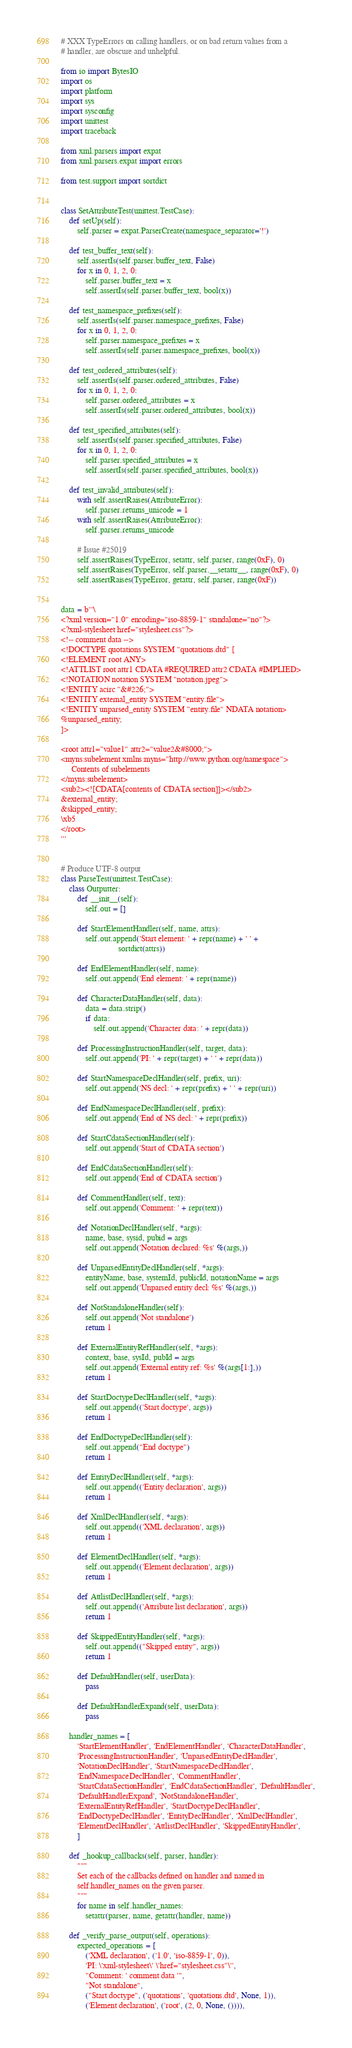<code> <loc_0><loc_0><loc_500><loc_500><_Python_># XXX TypeErrors on calling handlers, or on bad return values from a
# handler, are obscure and unhelpful.

from io import BytesIO
import os
import platform
import sys
import sysconfig
import unittest
import traceback

from xml.parsers import expat
from xml.parsers.expat import errors

from test.support import sortdict


class SetAttributeTest(unittest.TestCase):
    def setUp(self):
        self.parser = expat.ParserCreate(namespace_separator='!')

    def test_buffer_text(self):
        self.assertIs(self.parser.buffer_text, False)
        for x in 0, 1, 2, 0:
            self.parser.buffer_text = x
            self.assertIs(self.parser.buffer_text, bool(x))

    def test_namespace_prefixes(self):
        self.assertIs(self.parser.namespace_prefixes, False)
        for x in 0, 1, 2, 0:
            self.parser.namespace_prefixes = x
            self.assertIs(self.parser.namespace_prefixes, bool(x))

    def test_ordered_attributes(self):
        self.assertIs(self.parser.ordered_attributes, False)
        for x in 0, 1, 2, 0:
            self.parser.ordered_attributes = x
            self.assertIs(self.parser.ordered_attributes, bool(x))

    def test_specified_attributes(self):
        self.assertIs(self.parser.specified_attributes, False)
        for x in 0, 1, 2, 0:
            self.parser.specified_attributes = x
            self.assertIs(self.parser.specified_attributes, bool(x))

    def test_invalid_attributes(self):
        with self.assertRaises(AttributeError):
            self.parser.returns_unicode = 1
        with self.assertRaises(AttributeError):
            self.parser.returns_unicode

        # Issue #25019
        self.assertRaises(TypeError, setattr, self.parser, range(0xF), 0)
        self.assertRaises(TypeError, self.parser.__setattr__, range(0xF), 0)
        self.assertRaises(TypeError, getattr, self.parser, range(0xF))


data = b'''\
<?xml version="1.0" encoding="iso-8859-1" standalone="no"?>
<?xml-stylesheet href="stylesheet.css"?>
<!-- comment data -->
<!DOCTYPE quotations SYSTEM "quotations.dtd" [
<!ELEMENT root ANY>
<!ATTLIST root attr1 CDATA #REQUIRED attr2 CDATA #IMPLIED>
<!NOTATION notation SYSTEM "notation.jpeg">
<!ENTITY acirc "&#226;">
<!ENTITY external_entity SYSTEM "entity.file">
<!ENTITY unparsed_entity SYSTEM "entity.file" NDATA notation>
%unparsed_entity;
]>

<root attr1="value1" attr2="value2&#8000;">
<myns:subelement xmlns:myns="http://www.python.org/namespace">
     Contents of subelements
</myns:subelement>
<sub2><![CDATA[contents of CDATA section]]></sub2>
&external_entity;
&skipped_entity;
\xb5
</root>
'''


# Produce UTF-8 output
class ParseTest(unittest.TestCase):
    class Outputter:
        def __init__(self):
            self.out = []

        def StartElementHandler(self, name, attrs):
            self.out.append('Start element: ' + repr(name) + ' ' +
                            sortdict(attrs))

        def EndElementHandler(self, name):
            self.out.append('End element: ' + repr(name))

        def CharacterDataHandler(self, data):
            data = data.strip()
            if data:
                self.out.append('Character data: ' + repr(data))

        def ProcessingInstructionHandler(self, target, data):
            self.out.append('PI: ' + repr(target) + ' ' + repr(data))

        def StartNamespaceDeclHandler(self, prefix, uri):
            self.out.append('NS decl: ' + repr(prefix) + ' ' + repr(uri))

        def EndNamespaceDeclHandler(self, prefix):
            self.out.append('End of NS decl: ' + repr(prefix))

        def StartCdataSectionHandler(self):
            self.out.append('Start of CDATA section')

        def EndCdataSectionHandler(self):
            self.out.append('End of CDATA section')

        def CommentHandler(self, text):
            self.out.append('Comment: ' + repr(text))

        def NotationDeclHandler(self, *args):
            name, base, sysid, pubid = args
            self.out.append('Notation declared: %s' %(args,))

        def UnparsedEntityDeclHandler(self, *args):
            entityName, base, systemId, publicId, notationName = args
            self.out.append('Unparsed entity decl: %s' %(args,))

        def NotStandaloneHandler(self):
            self.out.append('Not standalone')
            return 1

        def ExternalEntityRefHandler(self, *args):
            context, base, sysId, pubId = args
            self.out.append('External entity ref: %s' %(args[1:],))
            return 1

        def StartDoctypeDeclHandler(self, *args):
            self.out.append(('Start doctype', args))
            return 1

        def EndDoctypeDeclHandler(self):
            self.out.append("End doctype")
            return 1

        def EntityDeclHandler(self, *args):
            self.out.append(('Entity declaration', args))
            return 1

        def XmlDeclHandler(self, *args):
            self.out.append(('XML declaration', args))
            return 1

        def ElementDeclHandler(self, *args):
            self.out.append(('Element declaration', args))
            return 1

        def AttlistDeclHandler(self, *args):
            self.out.append(('Attribute list declaration', args))
            return 1

        def SkippedEntityHandler(self, *args):
            self.out.append(("Skipped entity", args))
            return 1

        def DefaultHandler(self, userData):
            pass

        def DefaultHandlerExpand(self, userData):
            pass

    handler_names = [
        'StartElementHandler', 'EndElementHandler', 'CharacterDataHandler',
        'ProcessingInstructionHandler', 'UnparsedEntityDeclHandler',
        'NotationDeclHandler', 'StartNamespaceDeclHandler',
        'EndNamespaceDeclHandler', 'CommentHandler',
        'StartCdataSectionHandler', 'EndCdataSectionHandler', 'DefaultHandler',
        'DefaultHandlerExpand', 'NotStandaloneHandler',
        'ExternalEntityRefHandler', 'StartDoctypeDeclHandler',
        'EndDoctypeDeclHandler', 'EntityDeclHandler', 'XmlDeclHandler',
        'ElementDeclHandler', 'AttlistDeclHandler', 'SkippedEntityHandler',
        ]

    def _hookup_callbacks(self, parser, handler):
        """
        Set each of the callbacks defined on handler and named in
        self.handler_names on the given parser.
        """
        for name in self.handler_names:
            setattr(parser, name, getattr(handler, name))

    def _verify_parse_output(self, operations):
        expected_operations = [
            ('XML declaration', ('1.0', 'iso-8859-1', 0)),
            'PI: \'xml-stylesheet\' \'href="stylesheet.css"\'',
            "Comment: ' comment data '",
            "Not standalone",
            ("Start doctype", ('quotations', 'quotations.dtd', None, 1)),
            ('Element declaration', ('root', (2, 0, None, ()))),</code> 